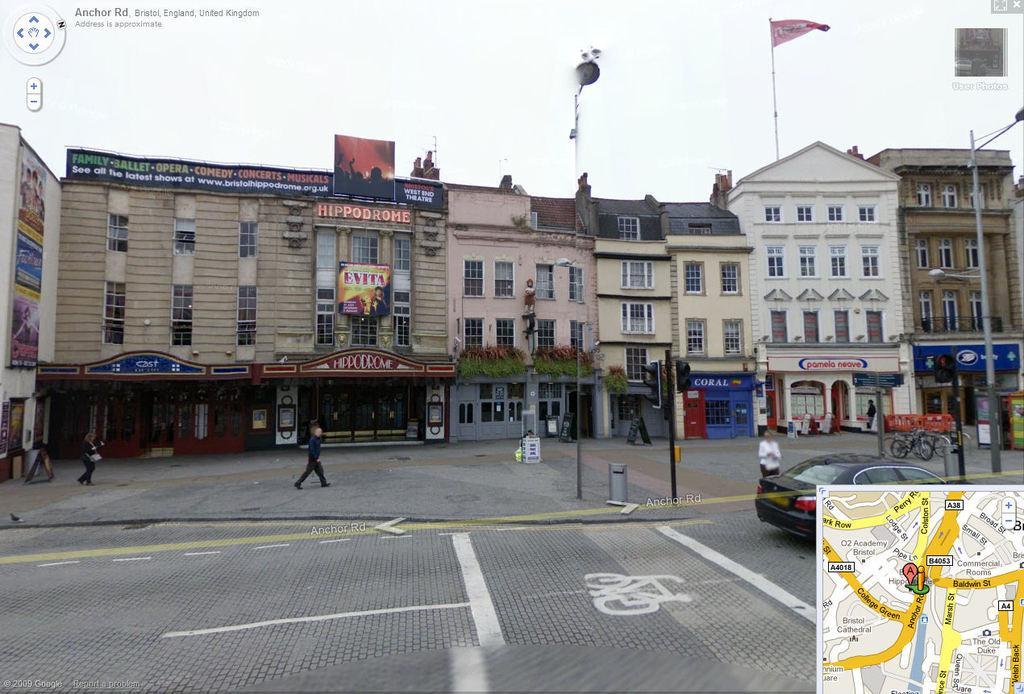Describe this image in one or two sentences. In this picture I can see buildings and few boards with some text and I can see a flag on the building and few poles and a pole light and I can see a car and few people walking and I can see few bicycles on the sidewalk and I can see map at the bottom right corner of the picture and I can see a cloudy sky and the picture looks like a screenshot. 